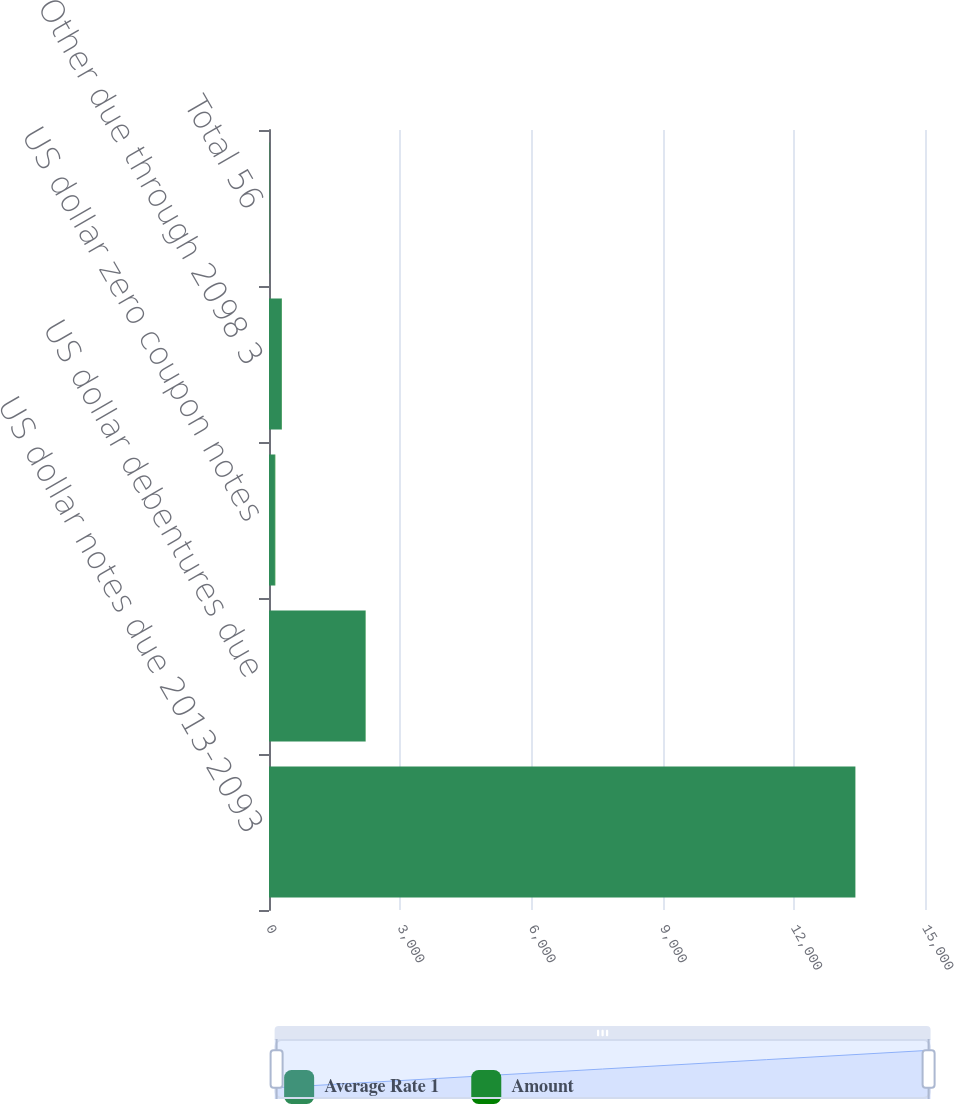<chart> <loc_0><loc_0><loc_500><loc_500><stacked_bar_chart><ecel><fcel>US dollar notes due 2013-2093<fcel>US dollar debentures due<fcel>US dollar zero coupon notes<fcel>Other due through 2098 3<fcel>Total 56<nl><fcel>Average Rate 1<fcel>13407<fcel>2207<fcel>135<fcel>291<fcel>8.4<nl><fcel>Amount<fcel>1.7<fcel>3.7<fcel>8.4<fcel>4.4<fcel>2.1<nl></chart> 